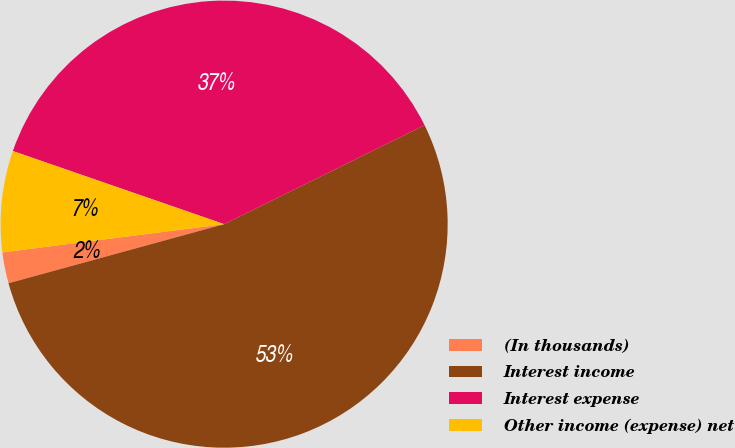<chart> <loc_0><loc_0><loc_500><loc_500><pie_chart><fcel>(In thousands)<fcel>Interest income<fcel>Interest expense<fcel>Other income (expense) net<nl><fcel>2.24%<fcel>53.04%<fcel>37.4%<fcel>7.32%<nl></chart> 